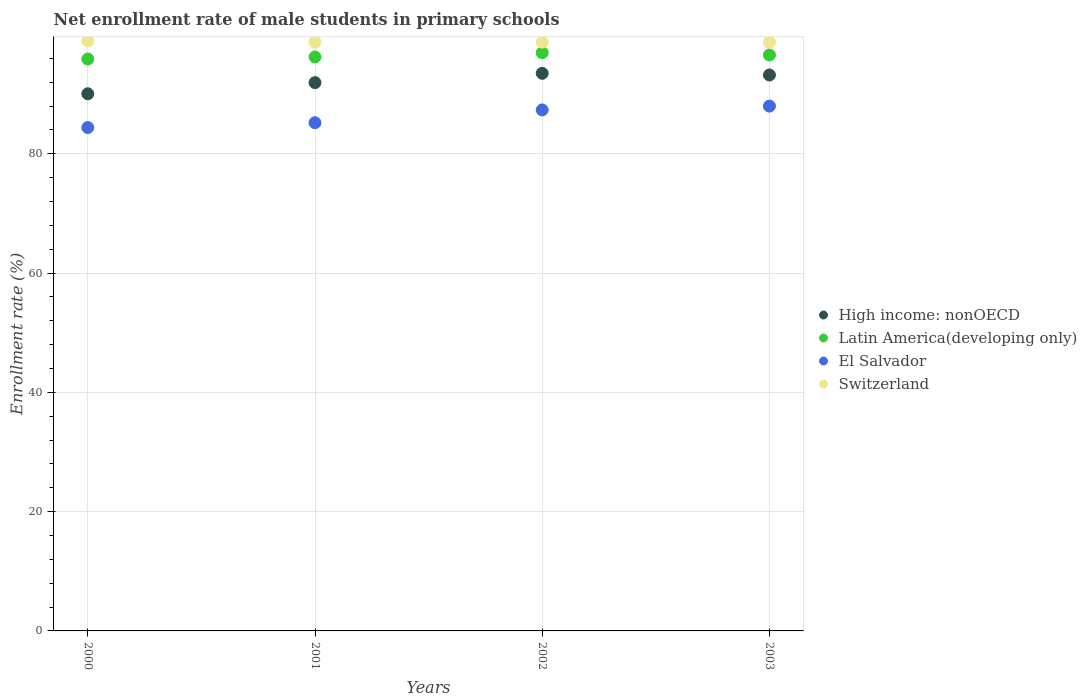How many different coloured dotlines are there?
Provide a short and direct response. 4. What is the net enrollment rate of male students in primary schools in Latin America(developing only) in 2000?
Make the answer very short. 95.88. Across all years, what is the maximum net enrollment rate of male students in primary schools in High income: nonOECD?
Provide a succinct answer. 93.49. Across all years, what is the minimum net enrollment rate of male students in primary schools in El Salvador?
Your response must be concise. 84.39. What is the total net enrollment rate of male students in primary schools in Switzerland in the graph?
Your answer should be compact. 395.04. What is the difference between the net enrollment rate of male students in primary schools in El Salvador in 2001 and that in 2002?
Your response must be concise. -2.15. What is the difference between the net enrollment rate of male students in primary schools in High income: nonOECD in 2001 and the net enrollment rate of male students in primary schools in El Salvador in 2000?
Offer a very short reply. 7.53. What is the average net enrollment rate of male students in primary schools in High income: nonOECD per year?
Offer a very short reply. 92.17. In the year 2001, what is the difference between the net enrollment rate of male students in primary schools in High income: nonOECD and net enrollment rate of male students in primary schools in El Salvador?
Give a very brief answer. 6.72. In how many years, is the net enrollment rate of male students in primary schools in High income: nonOECD greater than 56 %?
Offer a terse response. 4. What is the ratio of the net enrollment rate of male students in primary schools in El Salvador in 2002 to that in 2003?
Ensure brevity in your answer.  0.99. Is the difference between the net enrollment rate of male students in primary schools in High income: nonOECD in 2001 and 2002 greater than the difference between the net enrollment rate of male students in primary schools in El Salvador in 2001 and 2002?
Your answer should be compact. Yes. What is the difference between the highest and the second highest net enrollment rate of male students in primary schools in High income: nonOECD?
Provide a succinct answer. 0.29. What is the difference between the highest and the lowest net enrollment rate of male students in primary schools in El Salvador?
Provide a succinct answer. 3.59. In how many years, is the net enrollment rate of male students in primary schools in El Salvador greater than the average net enrollment rate of male students in primary schools in El Salvador taken over all years?
Offer a very short reply. 2. Is it the case that in every year, the sum of the net enrollment rate of male students in primary schools in Switzerland and net enrollment rate of male students in primary schools in Latin America(developing only)  is greater than the sum of net enrollment rate of male students in primary schools in High income: nonOECD and net enrollment rate of male students in primary schools in El Salvador?
Provide a short and direct response. Yes. Is it the case that in every year, the sum of the net enrollment rate of male students in primary schools in El Salvador and net enrollment rate of male students in primary schools in Switzerland  is greater than the net enrollment rate of male students in primary schools in Latin America(developing only)?
Offer a very short reply. Yes. Is the net enrollment rate of male students in primary schools in Switzerland strictly greater than the net enrollment rate of male students in primary schools in High income: nonOECD over the years?
Provide a succinct answer. Yes. Is the net enrollment rate of male students in primary schools in Latin America(developing only) strictly less than the net enrollment rate of male students in primary schools in High income: nonOECD over the years?
Provide a succinct answer. No. How many years are there in the graph?
Keep it short and to the point. 4. What is the difference between two consecutive major ticks on the Y-axis?
Provide a succinct answer. 20. Does the graph contain any zero values?
Make the answer very short. No. Does the graph contain grids?
Give a very brief answer. Yes. How many legend labels are there?
Ensure brevity in your answer.  4. How are the legend labels stacked?
Offer a very short reply. Vertical. What is the title of the graph?
Offer a very short reply. Net enrollment rate of male students in primary schools. What is the label or title of the Y-axis?
Ensure brevity in your answer.  Enrollment rate (%). What is the Enrollment rate (%) of High income: nonOECD in 2000?
Make the answer very short. 90.06. What is the Enrollment rate (%) of Latin America(developing only) in 2000?
Your response must be concise. 95.88. What is the Enrollment rate (%) in El Salvador in 2000?
Make the answer very short. 84.39. What is the Enrollment rate (%) in Switzerland in 2000?
Keep it short and to the point. 98.92. What is the Enrollment rate (%) of High income: nonOECD in 2001?
Provide a succinct answer. 91.92. What is the Enrollment rate (%) in Latin America(developing only) in 2001?
Give a very brief answer. 96.23. What is the Enrollment rate (%) in El Salvador in 2001?
Make the answer very short. 85.2. What is the Enrollment rate (%) of Switzerland in 2001?
Give a very brief answer. 98.72. What is the Enrollment rate (%) in High income: nonOECD in 2002?
Your answer should be very brief. 93.49. What is the Enrollment rate (%) in Latin America(developing only) in 2002?
Give a very brief answer. 96.94. What is the Enrollment rate (%) of El Salvador in 2002?
Your answer should be compact. 87.35. What is the Enrollment rate (%) of Switzerland in 2002?
Offer a terse response. 98.71. What is the Enrollment rate (%) of High income: nonOECD in 2003?
Provide a succinct answer. 93.2. What is the Enrollment rate (%) in Latin America(developing only) in 2003?
Your response must be concise. 96.56. What is the Enrollment rate (%) of El Salvador in 2003?
Offer a very short reply. 87.98. What is the Enrollment rate (%) in Switzerland in 2003?
Offer a terse response. 98.69. Across all years, what is the maximum Enrollment rate (%) in High income: nonOECD?
Ensure brevity in your answer.  93.49. Across all years, what is the maximum Enrollment rate (%) of Latin America(developing only)?
Your answer should be compact. 96.94. Across all years, what is the maximum Enrollment rate (%) of El Salvador?
Offer a terse response. 87.98. Across all years, what is the maximum Enrollment rate (%) of Switzerland?
Give a very brief answer. 98.92. Across all years, what is the minimum Enrollment rate (%) of High income: nonOECD?
Your answer should be very brief. 90.06. Across all years, what is the minimum Enrollment rate (%) in Latin America(developing only)?
Ensure brevity in your answer.  95.88. Across all years, what is the minimum Enrollment rate (%) in El Salvador?
Offer a terse response. 84.39. Across all years, what is the minimum Enrollment rate (%) of Switzerland?
Your answer should be compact. 98.69. What is the total Enrollment rate (%) of High income: nonOECD in the graph?
Provide a succinct answer. 368.67. What is the total Enrollment rate (%) in Latin America(developing only) in the graph?
Your answer should be compact. 385.6. What is the total Enrollment rate (%) of El Salvador in the graph?
Your answer should be very brief. 344.92. What is the total Enrollment rate (%) in Switzerland in the graph?
Offer a terse response. 395.04. What is the difference between the Enrollment rate (%) of High income: nonOECD in 2000 and that in 2001?
Ensure brevity in your answer.  -1.86. What is the difference between the Enrollment rate (%) of Latin America(developing only) in 2000 and that in 2001?
Keep it short and to the point. -0.34. What is the difference between the Enrollment rate (%) of El Salvador in 2000 and that in 2001?
Offer a very short reply. -0.8. What is the difference between the Enrollment rate (%) in Switzerland in 2000 and that in 2001?
Give a very brief answer. 0.2. What is the difference between the Enrollment rate (%) of High income: nonOECD in 2000 and that in 2002?
Ensure brevity in your answer.  -3.43. What is the difference between the Enrollment rate (%) of Latin America(developing only) in 2000 and that in 2002?
Your answer should be very brief. -1.06. What is the difference between the Enrollment rate (%) of El Salvador in 2000 and that in 2002?
Provide a succinct answer. -2.95. What is the difference between the Enrollment rate (%) in Switzerland in 2000 and that in 2002?
Make the answer very short. 0.21. What is the difference between the Enrollment rate (%) in High income: nonOECD in 2000 and that in 2003?
Offer a terse response. -3.14. What is the difference between the Enrollment rate (%) of Latin America(developing only) in 2000 and that in 2003?
Your answer should be very brief. -0.68. What is the difference between the Enrollment rate (%) in El Salvador in 2000 and that in 2003?
Ensure brevity in your answer.  -3.59. What is the difference between the Enrollment rate (%) of Switzerland in 2000 and that in 2003?
Offer a very short reply. 0.22. What is the difference between the Enrollment rate (%) of High income: nonOECD in 2001 and that in 2002?
Offer a very short reply. -1.57. What is the difference between the Enrollment rate (%) of Latin America(developing only) in 2001 and that in 2002?
Offer a very short reply. -0.71. What is the difference between the Enrollment rate (%) in El Salvador in 2001 and that in 2002?
Give a very brief answer. -2.15. What is the difference between the Enrollment rate (%) in Switzerland in 2001 and that in 2002?
Offer a very short reply. 0.01. What is the difference between the Enrollment rate (%) in High income: nonOECD in 2001 and that in 2003?
Give a very brief answer. -1.28. What is the difference between the Enrollment rate (%) in Latin America(developing only) in 2001 and that in 2003?
Make the answer very short. -0.33. What is the difference between the Enrollment rate (%) of El Salvador in 2001 and that in 2003?
Keep it short and to the point. -2.79. What is the difference between the Enrollment rate (%) of Switzerland in 2001 and that in 2003?
Provide a succinct answer. 0.02. What is the difference between the Enrollment rate (%) in High income: nonOECD in 2002 and that in 2003?
Ensure brevity in your answer.  0.29. What is the difference between the Enrollment rate (%) in Latin America(developing only) in 2002 and that in 2003?
Give a very brief answer. 0.38. What is the difference between the Enrollment rate (%) in El Salvador in 2002 and that in 2003?
Your response must be concise. -0.64. What is the difference between the Enrollment rate (%) of Switzerland in 2002 and that in 2003?
Provide a short and direct response. 0.02. What is the difference between the Enrollment rate (%) in High income: nonOECD in 2000 and the Enrollment rate (%) in Latin America(developing only) in 2001?
Your answer should be compact. -6.17. What is the difference between the Enrollment rate (%) in High income: nonOECD in 2000 and the Enrollment rate (%) in El Salvador in 2001?
Provide a succinct answer. 4.86. What is the difference between the Enrollment rate (%) of High income: nonOECD in 2000 and the Enrollment rate (%) of Switzerland in 2001?
Your answer should be compact. -8.66. What is the difference between the Enrollment rate (%) in Latin America(developing only) in 2000 and the Enrollment rate (%) in El Salvador in 2001?
Give a very brief answer. 10.68. What is the difference between the Enrollment rate (%) of Latin America(developing only) in 2000 and the Enrollment rate (%) of Switzerland in 2001?
Give a very brief answer. -2.84. What is the difference between the Enrollment rate (%) of El Salvador in 2000 and the Enrollment rate (%) of Switzerland in 2001?
Provide a succinct answer. -14.32. What is the difference between the Enrollment rate (%) in High income: nonOECD in 2000 and the Enrollment rate (%) in Latin America(developing only) in 2002?
Provide a short and direct response. -6.88. What is the difference between the Enrollment rate (%) in High income: nonOECD in 2000 and the Enrollment rate (%) in El Salvador in 2002?
Your response must be concise. 2.71. What is the difference between the Enrollment rate (%) in High income: nonOECD in 2000 and the Enrollment rate (%) in Switzerland in 2002?
Offer a very short reply. -8.65. What is the difference between the Enrollment rate (%) in Latin America(developing only) in 2000 and the Enrollment rate (%) in El Salvador in 2002?
Offer a terse response. 8.53. What is the difference between the Enrollment rate (%) of Latin America(developing only) in 2000 and the Enrollment rate (%) of Switzerland in 2002?
Ensure brevity in your answer.  -2.83. What is the difference between the Enrollment rate (%) in El Salvador in 2000 and the Enrollment rate (%) in Switzerland in 2002?
Provide a short and direct response. -14.32. What is the difference between the Enrollment rate (%) of High income: nonOECD in 2000 and the Enrollment rate (%) of Latin America(developing only) in 2003?
Ensure brevity in your answer.  -6.5. What is the difference between the Enrollment rate (%) in High income: nonOECD in 2000 and the Enrollment rate (%) in El Salvador in 2003?
Keep it short and to the point. 2.07. What is the difference between the Enrollment rate (%) of High income: nonOECD in 2000 and the Enrollment rate (%) of Switzerland in 2003?
Your response must be concise. -8.64. What is the difference between the Enrollment rate (%) of Latin America(developing only) in 2000 and the Enrollment rate (%) of El Salvador in 2003?
Ensure brevity in your answer.  7.9. What is the difference between the Enrollment rate (%) in Latin America(developing only) in 2000 and the Enrollment rate (%) in Switzerland in 2003?
Your response must be concise. -2.81. What is the difference between the Enrollment rate (%) in El Salvador in 2000 and the Enrollment rate (%) in Switzerland in 2003?
Your response must be concise. -14.3. What is the difference between the Enrollment rate (%) in High income: nonOECD in 2001 and the Enrollment rate (%) in Latin America(developing only) in 2002?
Offer a terse response. -5.02. What is the difference between the Enrollment rate (%) of High income: nonOECD in 2001 and the Enrollment rate (%) of El Salvador in 2002?
Your answer should be very brief. 4.57. What is the difference between the Enrollment rate (%) in High income: nonOECD in 2001 and the Enrollment rate (%) in Switzerland in 2002?
Your answer should be compact. -6.79. What is the difference between the Enrollment rate (%) of Latin America(developing only) in 2001 and the Enrollment rate (%) of El Salvador in 2002?
Provide a succinct answer. 8.88. What is the difference between the Enrollment rate (%) in Latin America(developing only) in 2001 and the Enrollment rate (%) in Switzerland in 2002?
Provide a succinct answer. -2.48. What is the difference between the Enrollment rate (%) in El Salvador in 2001 and the Enrollment rate (%) in Switzerland in 2002?
Your answer should be compact. -13.51. What is the difference between the Enrollment rate (%) of High income: nonOECD in 2001 and the Enrollment rate (%) of Latin America(developing only) in 2003?
Offer a terse response. -4.64. What is the difference between the Enrollment rate (%) of High income: nonOECD in 2001 and the Enrollment rate (%) of El Salvador in 2003?
Provide a short and direct response. 3.94. What is the difference between the Enrollment rate (%) in High income: nonOECD in 2001 and the Enrollment rate (%) in Switzerland in 2003?
Provide a succinct answer. -6.77. What is the difference between the Enrollment rate (%) in Latin America(developing only) in 2001 and the Enrollment rate (%) in El Salvador in 2003?
Make the answer very short. 8.24. What is the difference between the Enrollment rate (%) in Latin America(developing only) in 2001 and the Enrollment rate (%) in Switzerland in 2003?
Ensure brevity in your answer.  -2.47. What is the difference between the Enrollment rate (%) in El Salvador in 2001 and the Enrollment rate (%) in Switzerland in 2003?
Offer a very short reply. -13.5. What is the difference between the Enrollment rate (%) of High income: nonOECD in 2002 and the Enrollment rate (%) of Latin America(developing only) in 2003?
Ensure brevity in your answer.  -3.07. What is the difference between the Enrollment rate (%) of High income: nonOECD in 2002 and the Enrollment rate (%) of El Salvador in 2003?
Provide a succinct answer. 5.5. What is the difference between the Enrollment rate (%) of High income: nonOECD in 2002 and the Enrollment rate (%) of Switzerland in 2003?
Keep it short and to the point. -5.21. What is the difference between the Enrollment rate (%) of Latin America(developing only) in 2002 and the Enrollment rate (%) of El Salvador in 2003?
Make the answer very short. 8.95. What is the difference between the Enrollment rate (%) of Latin America(developing only) in 2002 and the Enrollment rate (%) of Switzerland in 2003?
Make the answer very short. -1.76. What is the difference between the Enrollment rate (%) of El Salvador in 2002 and the Enrollment rate (%) of Switzerland in 2003?
Ensure brevity in your answer.  -11.35. What is the average Enrollment rate (%) of High income: nonOECD per year?
Provide a succinct answer. 92.17. What is the average Enrollment rate (%) of Latin America(developing only) per year?
Your answer should be very brief. 96.4. What is the average Enrollment rate (%) of El Salvador per year?
Give a very brief answer. 86.23. What is the average Enrollment rate (%) in Switzerland per year?
Provide a short and direct response. 98.76. In the year 2000, what is the difference between the Enrollment rate (%) of High income: nonOECD and Enrollment rate (%) of Latin America(developing only)?
Your response must be concise. -5.82. In the year 2000, what is the difference between the Enrollment rate (%) of High income: nonOECD and Enrollment rate (%) of El Salvador?
Offer a very short reply. 5.66. In the year 2000, what is the difference between the Enrollment rate (%) in High income: nonOECD and Enrollment rate (%) in Switzerland?
Your answer should be compact. -8.86. In the year 2000, what is the difference between the Enrollment rate (%) of Latin America(developing only) and Enrollment rate (%) of El Salvador?
Provide a succinct answer. 11.49. In the year 2000, what is the difference between the Enrollment rate (%) of Latin America(developing only) and Enrollment rate (%) of Switzerland?
Make the answer very short. -3.04. In the year 2000, what is the difference between the Enrollment rate (%) of El Salvador and Enrollment rate (%) of Switzerland?
Offer a very short reply. -14.52. In the year 2001, what is the difference between the Enrollment rate (%) in High income: nonOECD and Enrollment rate (%) in Latin America(developing only)?
Provide a short and direct response. -4.3. In the year 2001, what is the difference between the Enrollment rate (%) of High income: nonOECD and Enrollment rate (%) of El Salvador?
Offer a terse response. 6.72. In the year 2001, what is the difference between the Enrollment rate (%) in High income: nonOECD and Enrollment rate (%) in Switzerland?
Provide a short and direct response. -6.8. In the year 2001, what is the difference between the Enrollment rate (%) in Latin America(developing only) and Enrollment rate (%) in El Salvador?
Provide a succinct answer. 11.03. In the year 2001, what is the difference between the Enrollment rate (%) of Latin America(developing only) and Enrollment rate (%) of Switzerland?
Provide a succinct answer. -2.49. In the year 2001, what is the difference between the Enrollment rate (%) in El Salvador and Enrollment rate (%) in Switzerland?
Provide a short and direct response. -13.52. In the year 2002, what is the difference between the Enrollment rate (%) of High income: nonOECD and Enrollment rate (%) of Latin America(developing only)?
Your answer should be compact. -3.45. In the year 2002, what is the difference between the Enrollment rate (%) in High income: nonOECD and Enrollment rate (%) in El Salvador?
Offer a very short reply. 6.14. In the year 2002, what is the difference between the Enrollment rate (%) in High income: nonOECD and Enrollment rate (%) in Switzerland?
Your response must be concise. -5.22. In the year 2002, what is the difference between the Enrollment rate (%) in Latin America(developing only) and Enrollment rate (%) in El Salvador?
Your answer should be very brief. 9.59. In the year 2002, what is the difference between the Enrollment rate (%) of Latin America(developing only) and Enrollment rate (%) of Switzerland?
Offer a very short reply. -1.77. In the year 2002, what is the difference between the Enrollment rate (%) of El Salvador and Enrollment rate (%) of Switzerland?
Give a very brief answer. -11.36. In the year 2003, what is the difference between the Enrollment rate (%) in High income: nonOECD and Enrollment rate (%) in Latin America(developing only)?
Your response must be concise. -3.36. In the year 2003, what is the difference between the Enrollment rate (%) of High income: nonOECD and Enrollment rate (%) of El Salvador?
Keep it short and to the point. 5.22. In the year 2003, what is the difference between the Enrollment rate (%) in High income: nonOECD and Enrollment rate (%) in Switzerland?
Make the answer very short. -5.49. In the year 2003, what is the difference between the Enrollment rate (%) in Latin America(developing only) and Enrollment rate (%) in El Salvador?
Your response must be concise. 8.57. In the year 2003, what is the difference between the Enrollment rate (%) in Latin America(developing only) and Enrollment rate (%) in Switzerland?
Make the answer very short. -2.14. In the year 2003, what is the difference between the Enrollment rate (%) in El Salvador and Enrollment rate (%) in Switzerland?
Offer a terse response. -10.71. What is the ratio of the Enrollment rate (%) in High income: nonOECD in 2000 to that in 2001?
Keep it short and to the point. 0.98. What is the ratio of the Enrollment rate (%) in Latin America(developing only) in 2000 to that in 2001?
Offer a very short reply. 1. What is the ratio of the Enrollment rate (%) of El Salvador in 2000 to that in 2001?
Your answer should be very brief. 0.99. What is the ratio of the Enrollment rate (%) of Switzerland in 2000 to that in 2001?
Ensure brevity in your answer.  1. What is the ratio of the Enrollment rate (%) of High income: nonOECD in 2000 to that in 2002?
Provide a short and direct response. 0.96. What is the ratio of the Enrollment rate (%) in Latin America(developing only) in 2000 to that in 2002?
Ensure brevity in your answer.  0.99. What is the ratio of the Enrollment rate (%) in El Salvador in 2000 to that in 2002?
Your answer should be very brief. 0.97. What is the ratio of the Enrollment rate (%) in Switzerland in 2000 to that in 2002?
Your answer should be very brief. 1. What is the ratio of the Enrollment rate (%) of High income: nonOECD in 2000 to that in 2003?
Offer a terse response. 0.97. What is the ratio of the Enrollment rate (%) of Latin America(developing only) in 2000 to that in 2003?
Your response must be concise. 0.99. What is the ratio of the Enrollment rate (%) in El Salvador in 2000 to that in 2003?
Your answer should be very brief. 0.96. What is the ratio of the Enrollment rate (%) in High income: nonOECD in 2001 to that in 2002?
Your answer should be compact. 0.98. What is the ratio of the Enrollment rate (%) of El Salvador in 2001 to that in 2002?
Give a very brief answer. 0.98. What is the ratio of the Enrollment rate (%) in Switzerland in 2001 to that in 2002?
Your response must be concise. 1. What is the ratio of the Enrollment rate (%) of High income: nonOECD in 2001 to that in 2003?
Provide a succinct answer. 0.99. What is the ratio of the Enrollment rate (%) of Latin America(developing only) in 2001 to that in 2003?
Make the answer very short. 1. What is the ratio of the Enrollment rate (%) of El Salvador in 2001 to that in 2003?
Provide a short and direct response. 0.97. What is the ratio of the Enrollment rate (%) of Switzerland in 2001 to that in 2003?
Provide a succinct answer. 1. What is the ratio of the Enrollment rate (%) of High income: nonOECD in 2002 to that in 2003?
Provide a succinct answer. 1. What is the difference between the highest and the second highest Enrollment rate (%) in High income: nonOECD?
Give a very brief answer. 0.29. What is the difference between the highest and the second highest Enrollment rate (%) in Latin America(developing only)?
Offer a very short reply. 0.38. What is the difference between the highest and the second highest Enrollment rate (%) of El Salvador?
Provide a succinct answer. 0.64. What is the difference between the highest and the second highest Enrollment rate (%) of Switzerland?
Make the answer very short. 0.2. What is the difference between the highest and the lowest Enrollment rate (%) of High income: nonOECD?
Give a very brief answer. 3.43. What is the difference between the highest and the lowest Enrollment rate (%) in Latin America(developing only)?
Your answer should be very brief. 1.06. What is the difference between the highest and the lowest Enrollment rate (%) of El Salvador?
Give a very brief answer. 3.59. What is the difference between the highest and the lowest Enrollment rate (%) of Switzerland?
Your response must be concise. 0.22. 